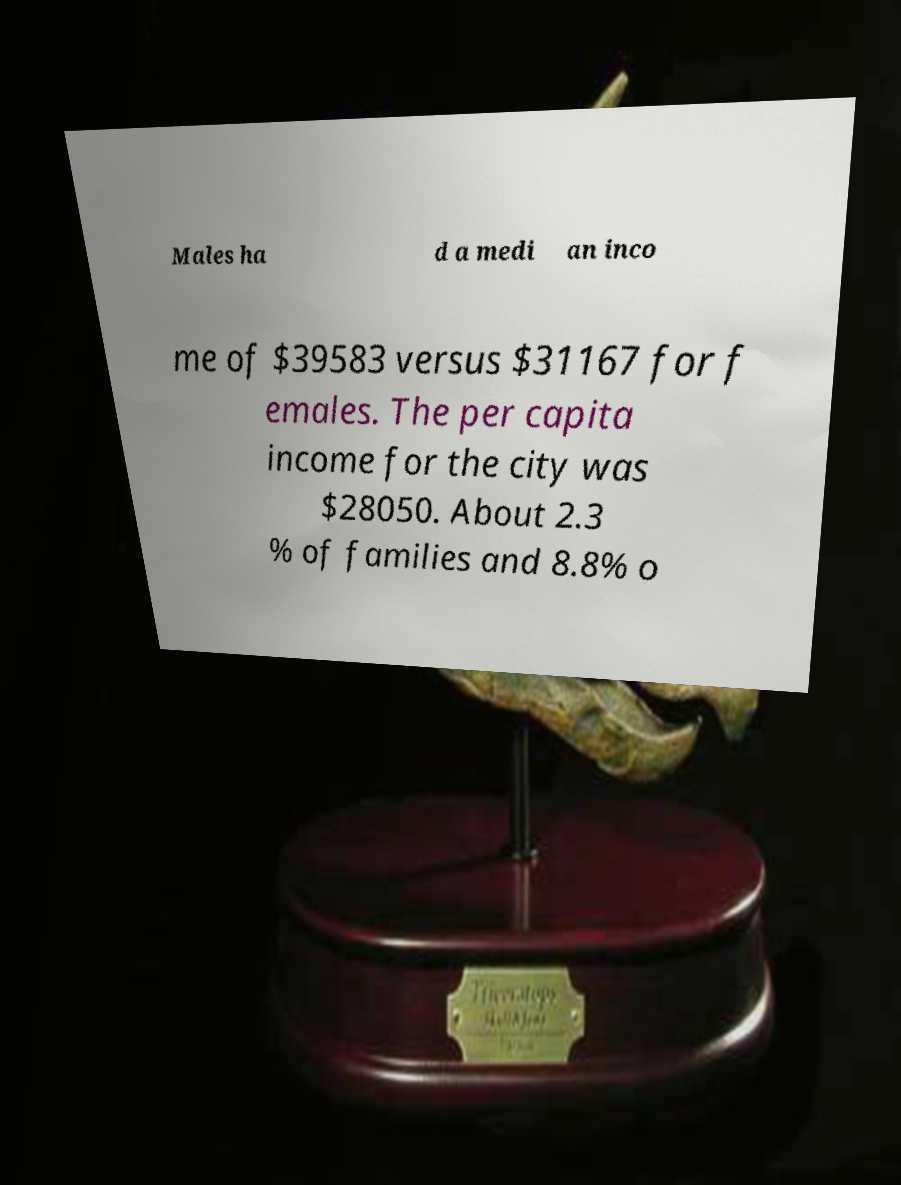Could you assist in decoding the text presented in this image and type it out clearly? Males ha d a medi an inco me of $39583 versus $31167 for f emales. The per capita income for the city was $28050. About 2.3 % of families and 8.8% o 